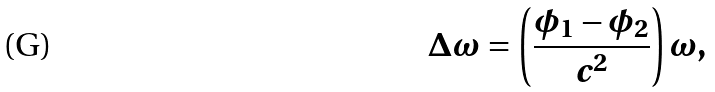<formula> <loc_0><loc_0><loc_500><loc_500>\Delta \omega = \left ( \frac { \phi _ { 1 } - \phi _ { 2 } } { c ^ { 2 } } \right ) \omega ,</formula> 